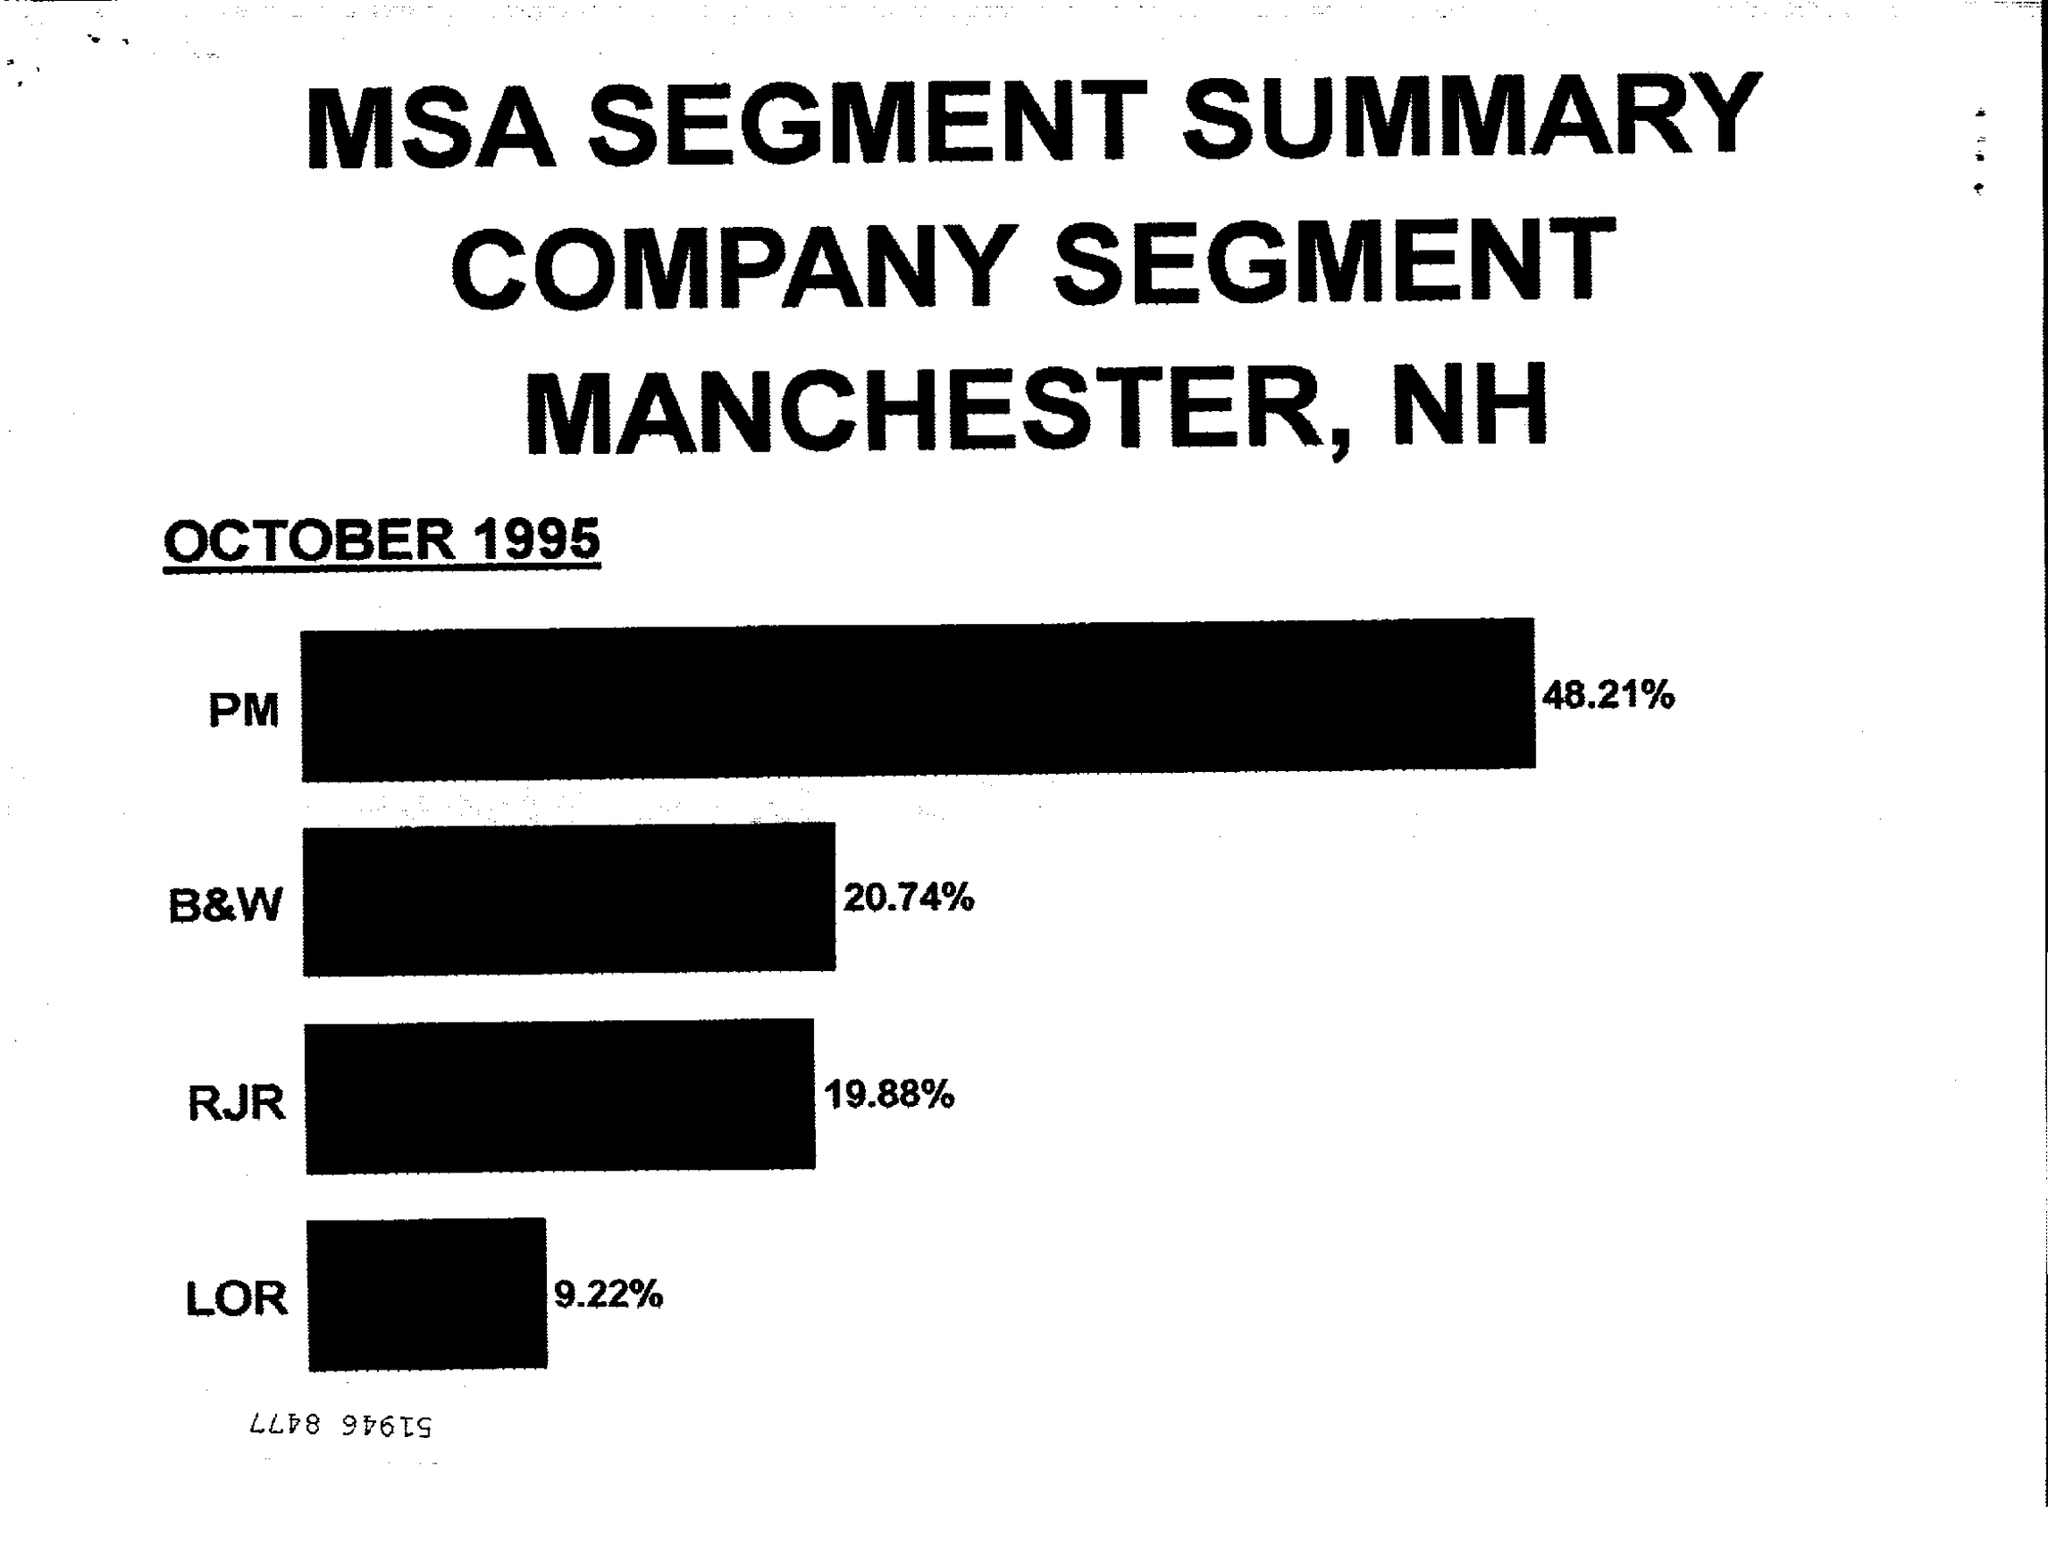What % is PM?
Provide a short and direct response. 48.21. What % is RJR ?
Your answer should be very brief. 19.88. What % is LOR ?
Give a very brief answer. 9.22. 